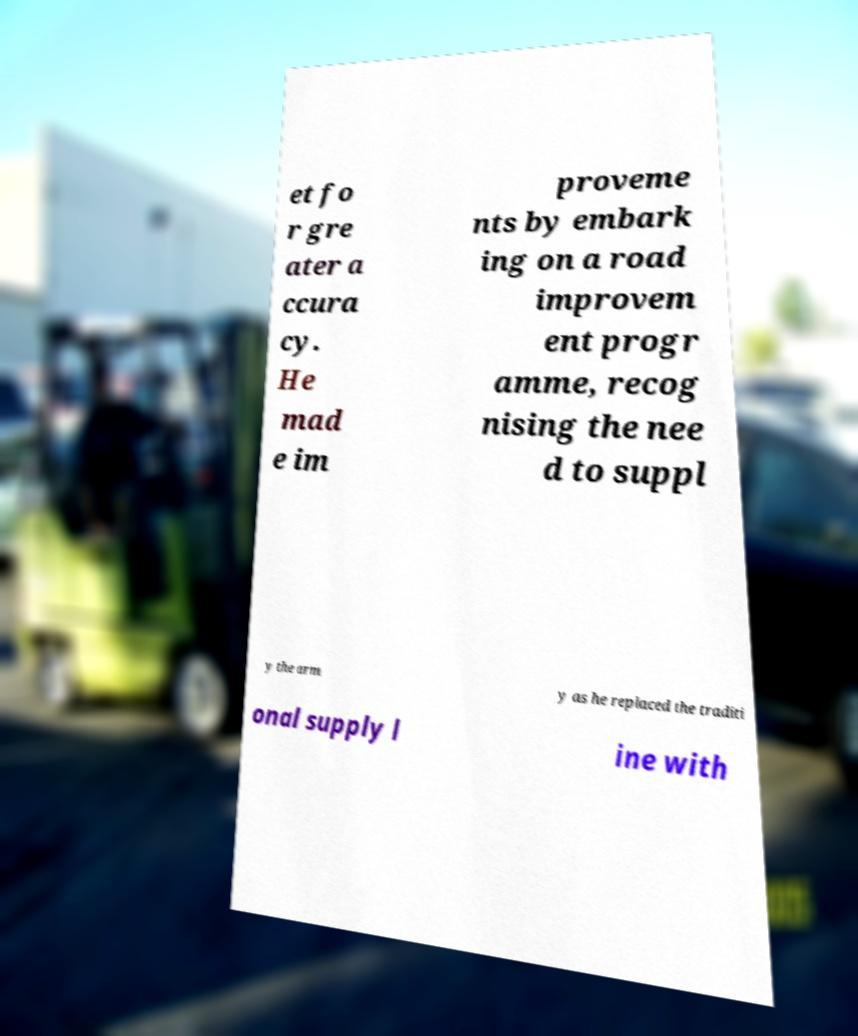Can you accurately transcribe the text from the provided image for me? et fo r gre ater a ccura cy. He mad e im proveme nts by embark ing on a road improvem ent progr amme, recog nising the nee d to suppl y the arm y as he replaced the traditi onal supply l ine with 